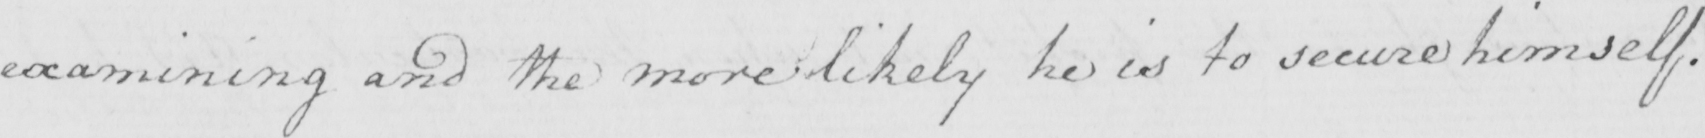What does this handwritten line say? examining and the more likely he is to secure himself . 